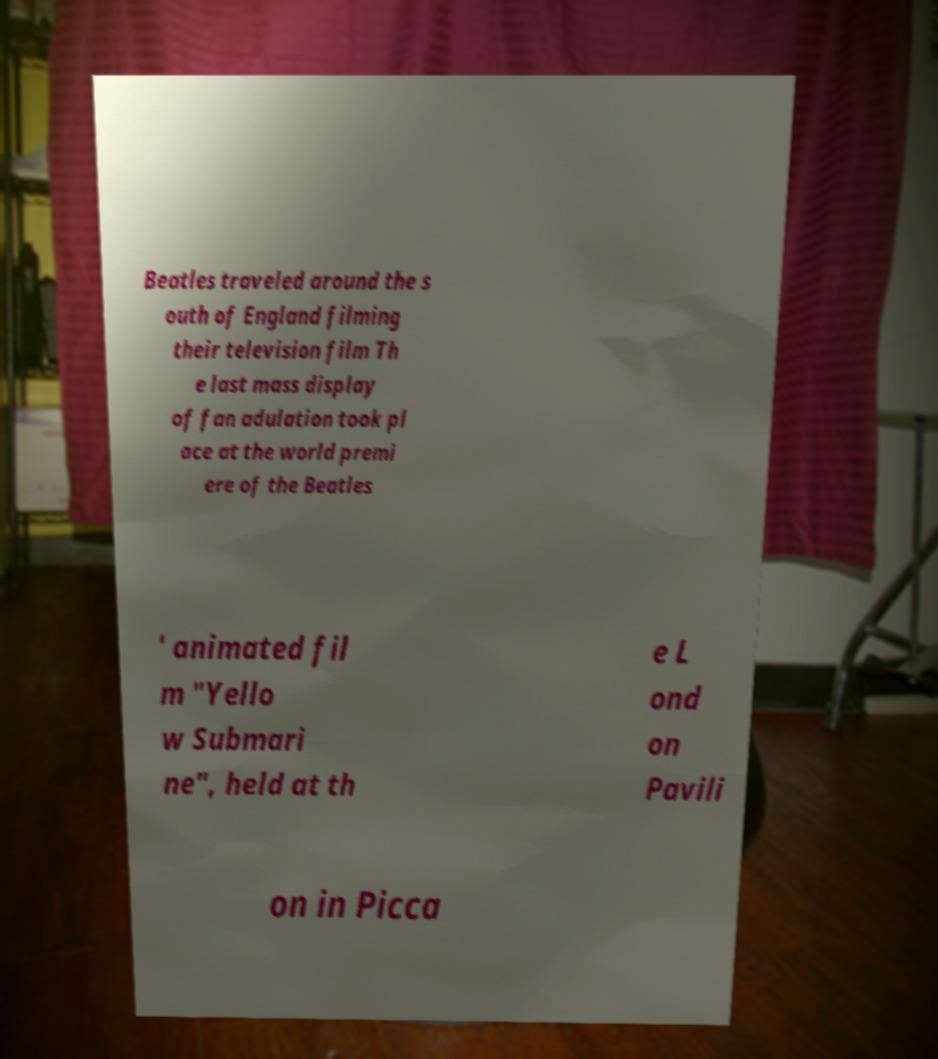I need the written content from this picture converted into text. Can you do that? Beatles traveled around the s outh of England filming their television film Th e last mass display of fan adulation took pl ace at the world premi ere of the Beatles ' animated fil m "Yello w Submari ne", held at th e L ond on Pavili on in Picca 